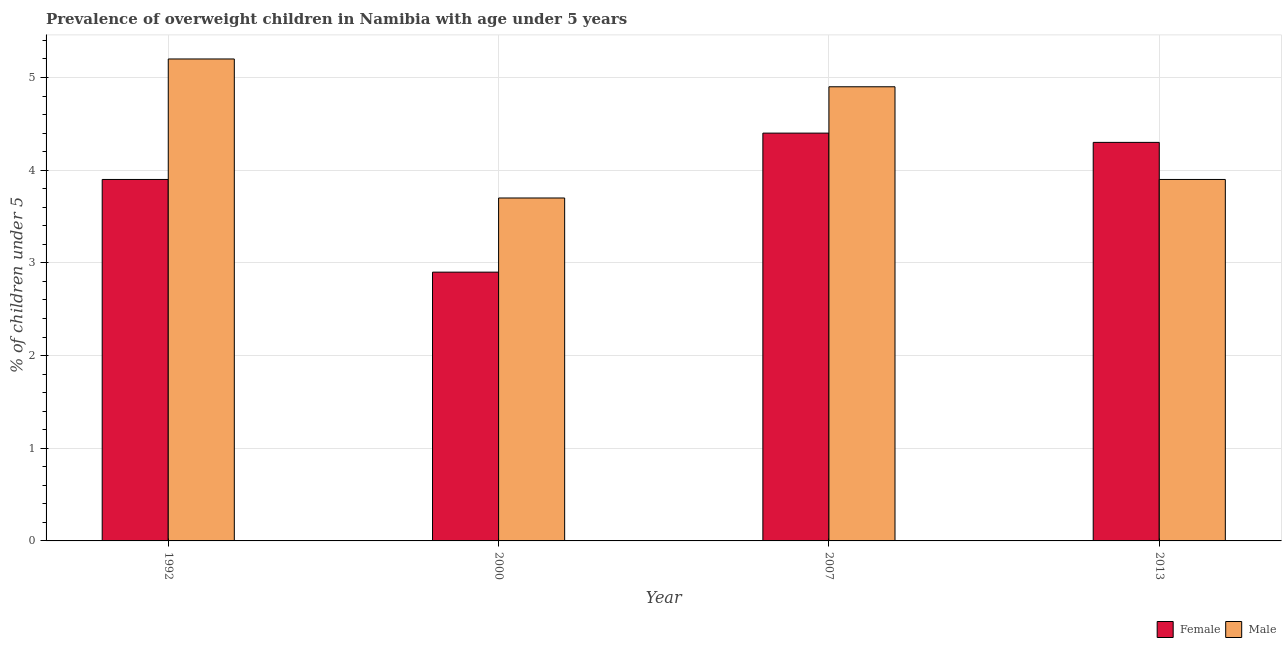Are the number of bars per tick equal to the number of legend labels?
Offer a very short reply. Yes. Are the number of bars on each tick of the X-axis equal?
Offer a terse response. Yes. How many bars are there on the 4th tick from the left?
Ensure brevity in your answer.  2. How many bars are there on the 1st tick from the right?
Offer a terse response. 2. What is the label of the 2nd group of bars from the left?
Your answer should be compact. 2000. In how many cases, is the number of bars for a given year not equal to the number of legend labels?
Give a very brief answer. 0. What is the percentage of obese male children in 2000?
Your answer should be very brief. 3.7. Across all years, what is the maximum percentage of obese female children?
Ensure brevity in your answer.  4.4. Across all years, what is the minimum percentage of obese female children?
Keep it short and to the point. 2.9. In which year was the percentage of obese female children maximum?
Your response must be concise. 2007. What is the total percentage of obese female children in the graph?
Your answer should be very brief. 15.5. What is the difference between the percentage of obese male children in 2000 and that in 2007?
Your answer should be very brief. -1.2. What is the difference between the percentage of obese male children in 1992 and the percentage of obese female children in 2007?
Your response must be concise. 0.3. What is the average percentage of obese female children per year?
Make the answer very short. 3.88. In the year 2007, what is the difference between the percentage of obese male children and percentage of obese female children?
Your response must be concise. 0. What is the ratio of the percentage of obese male children in 2000 to that in 2013?
Your answer should be compact. 0.95. Is the percentage of obese male children in 2000 less than that in 2013?
Your answer should be very brief. Yes. What is the difference between the highest and the second highest percentage of obese male children?
Keep it short and to the point. 0.3. In how many years, is the percentage of obese male children greater than the average percentage of obese male children taken over all years?
Your response must be concise. 2. Is the sum of the percentage of obese female children in 1992 and 2007 greater than the maximum percentage of obese male children across all years?
Offer a very short reply. Yes. What does the 1st bar from the right in 2000 represents?
Your response must be concise. Male. How many bars are there?
Provide a succinct answer. 8. Are all the bars in the graph horizontal?
Keep it short and to the point. No. How many years are there in the graph?
Your answer should be very brief. 4. What is the difference between two consecutive major ticks on the Y-axis?
Give a very brief answer. 1. Are the values on the major ticks of Y-axis written in scientific E-notation?
Make the answer very short. No. Does the graph contain grids?
Provide a short and direct response. Yes. How many legend labels are there?
Provide a short and direct response. 2. How are the legend labels stacked?
Your answer should be compact. Horizontal. What is the title of the graph?
Keep it short and to the point. Prevalence of overweight children in Namibia with age under 5 years. What is the label or title of the X-axis?
Make the answer very short. Year. What is the label or title of the Y-axis?
Give a very brief answer.  % of children under 5. What is the  % of children under 5 of Female in 1992?
Your response must be concise. 3.9. What is the  % of children under 5 in Male in 1992?
Keep it short and to the point. 5.2. What is the  % of children under 5 of Female in 2000?
Provide a succinct answer. 2.9. What is the  % of children under 5 in Male in 2000?
Offer a terse response. 3.7. What is the  % of children under 5 of Female in 2007?
Your answer should be very brief. 4.4. What is the  % of children under 5 in Male in 2007?
Offer a terse response. 4.9. What is the  % of children under 5 of Female in 2013?
Your response must be concise. 4.3. What is the  % of children under 5 of Male in 2013?
Your answer should be compact. 3.9. Across all years, what is the maximum  % of children under 5 of Female?
Provide a succinct answer. 4.4. Across all years, what is the maximum  % of children under 5 in Male?
Offer a very short reply. 5.2. Across all years, what is the minimum  % of children under 5 in Female?
Provide a short and direct response. 2.9. Across all years, what is the minimum  % of children under 5 in Male?
Ensure brevity in your answer.  3.7. What is the total  % of children under 5 of Female in the graph?
Keep it short and to the point. 15.5. What is the difference between the  % of children under 5 of Male in 1992 and that in 2000?
Offer a terse response. 1.5. What is the difference between the  % of children under 5 in Female in 1992 and that in 2013?
Provide a succinct answer. -0.4. What is the difference between the  % of children under 5 in Male in 1992 and that in 2013?
Ensure brevity in your answer.  1.3. What is the difference between the  % of children under 5 of Female in 2000 and that in 2013?
Your answer should be compact. -1.4. What is the difference between the  % of children under 5 of Male in 2007 and that in 2013?
Make the answer very short. 1. What is the difference between the  % of children under 5 in Female in 1992 and the  % of children under 5 in Male in 2000?
Offer a very short reply. 0.2. What is the difference between the  % of children under 5 of Female in 1992 and the  % of children under 5 of Male in 2013?
Provide a short and direct response. 0. What is the difference between the  % of children under 5 in Female in 2000 and the  % of children under 5 in Male in 2007?
Ensure brevity in your answer.  -2. What is the difference between the  % of children under 5 in Female in 2007 and the  % of children under 5 in Male in 2013?
Your answer should be very brief. 0.5. What is the average  % of children under 5 of Female per year?
Your answer should be very brief. 3.88. What is the average  % of children under 5 in Male per year?
Provide a short and direct response. 4.42. In the year 1992, what is the difference between the  % of children under 5 of Female and  % of children under 5 of Male?
Offer a very short reply. -1.3. In the year 2007, what is the difference between the  % of children under 5 of Female and  % of children under 5 of Male?
Offer a very short reply. -0.5. What is the ratio of the  % of children under 5 of Female in 1992 to that in 2000?
Your answer should be compact. 1.34. What is the ratio of the  % of children under 5 of Male in 1992 to that in 2000?
Your answer should be very brief. 1.41. What is the ratio of the  % of children under 5 of Female in 1992 to that in 2007?
Keep it short and to the point. 0.89. What is the ratio of the  % of children under 5 of Male in 1992 to that in 2007?
Make the answer very short. 1.06. What is the ratio of the  % of children under 5 of Female in 1992 to that in 2013?
Keep it short and to the point. 0.91. What is the ratio of the  % of children under 5 in Female in 2000 to that in 2007?
Your answer should be compact. 0.66. What is the ratio of the  % of children under 5 of Male in 2000 to that in 2007?
Offer a very short reply. 0.76. What is the ratio of the  % of children under 5 in Female in 2000 to that in 2013?
Your response must be concise. 0.67. What is the ratio of the  % of children under 5 of Male in 2000 to that in 2013?
Keep it short and to the point. 0.95. What is the ratio of the  % of children under 5 in Female in 2007 to that in 2013?
Offer a terse response. 1.02. What is the ratio of the  % of children under 5 of Male in 2007 to that in 2013?
Your answer should be very brief. 1.26. What is the difference between the highest and the second highest  % of children under 5 of Female?
Your answer should be compact. 0.1. What is the difference between the highest and the second highest  % of children under 5 of Male?
Keep it short and to the point. 0.3. What is the difference between the highest and the lowest  % of children under 5 in Female?
Give a very brief answer. 1.5. 